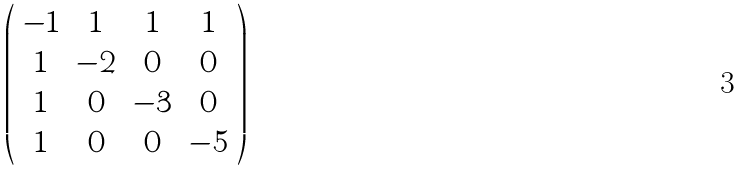Convert formula to latex. <formula><loc_0><loc_0><loc_500><loc_500>\left ( \begin{array} { c c c c } - 1 & 1 & 1 & 1 \\ 1 & - 2 & 0 & 0 \\ 1 & 0 & - 3 & 0 \\ 1 & 0 & 0 & - 5 \\ \end{array} \right )</formula> 